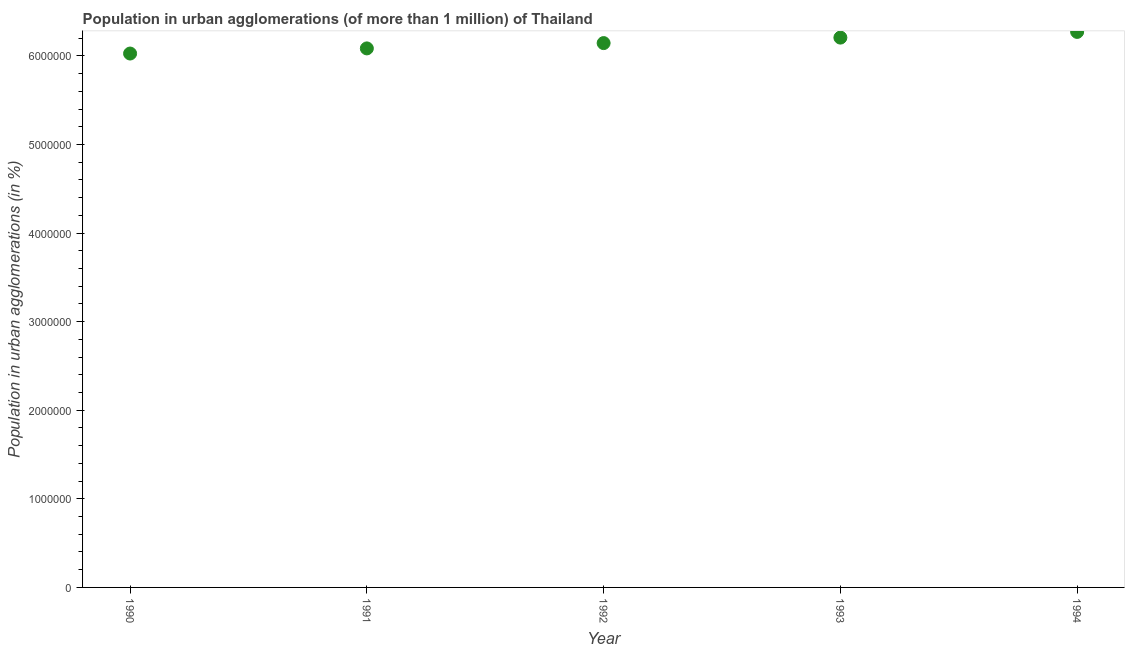What is the population in urban agglomerations in 1992?
Offer a terse response. 6.14e+06. Across all years, what is the maximum population in urban agglomerations?
Your response must be concise. 6.27e+06. Across all years, what is the minimum population in urban agglomerations?
Provide a short and direct response. 6.03e+06. What is the sum of the population in urban agglomerations?
Your response must be concise. 3.07e+07. What is the difference between the population in urban agglomerations in 1991 and 1993?
Provide a succinct answer. -1.22e+05. What is the average population in urban agglomerations per year?
Keep it short and to the point. 6.15e+06. What is the median population in urban agglomerations?
Offer a terse response. 6.14e+06. In how many years, is the population in urban agglomerations greater than 2000000 %?
Offer a terse response. 5. What is the ratio of the population in urban agglomerations in 1991 to that in 1993?
Provide a succinct answer. 0.98. Is the difference between the population in urban agglomerations in 1992 and 1994 greater than the difference between any two years?
Make the answer very short. No. What is the difference between the highest and the second highest population in urban agglomerations?
Make the answer very short. 6.43e+04. Is the sum of the population in urban agglomerations in 1990 and 1993 greater than the maximum population in urban agglomerations across all years?
Keep it short and to the point. Yes. What is the difference between the highest and the lowest population in urban agglomerations?
Offer a very short reply. 2.44e+05. How many dotlines are there?
Give a very brief answer. 1. Are the values on the major ticks of Y-axis written in scientific E-notation?
Make the answer very short. No. What is the title of the graph?
Provide a short and direct response. Population in urban agglomerations (of more than 1 million) of Thailand. What is the label or title of the X-axis?
Make the answer very short. Year. What is the label or title of the Y-axis?
Ensure brevity in your answer.  Population in urban agglomerations (in %). What is the Population in urban agglomerations (in %) in 1990?
Your response must be concise. 6.03e+06. What is the Population in urban agglomerations (in %) in 1991?
Your answer should be compact. 6.08e+06. What is the Population in urban agglomerations (in %) in 1992?
Ensure brevity in your answer.  6.14e+06. What is the Population in urban agglomerations (in %) in 1993?
Your answer should be very brief. 6.21e+06. What is the Population in urban agglomerations (in %) in 1994?
Provide a short and direct response. 6.27e+06. What is the difference between the Population in urban agglomerations (in %) in 1990 and 1991?
Provide a succinct answer. -5.79e+04. What is the difference between the Population in urban agglomerations (in %) in 1990 and 1992?
Keep it short and to the point. -1.18e+05. What is the difference between the Population in urban agglomerations (in %) in 1990 and 1993?
Your response must be concise. -1.80e+05. What is the difference between the Population in urban agglomerations (in %) in 1990 and 1994?
Offer a terse response. -2.44e+05. What is the difference between the Population in urban agglomerations (in %) in 1991 and 1992?
Your response must be concise. -6.00e+04. What is the difference between the Population in urban agglomerations (in %) in 1991 and 1993?
Give a very brief answer. -1.22e+05. What is the difference between the Population in urban agglomerations (in %) in 1991 and 1994?
Offer a terse response. -1.86e+05. What is the difference between the Population in urban agglomerations (in %) in 1992 and 1993?
Keep it short and to the point. -6.19e+04. What is the difference between the Population in urban agglomerations (in %) in 1992 and 1994?
Your response must be concise. -1.26e+05. What is the difference between the Population in urban agglomerations (in %) in 1993 and 1994?
Your answer should be very brief. -6.43e+04. What is the ratio of the Population in urban agglomerations (in %) in 1990 to that in 1992?
Provide a short and direct response. 0.98. What is the ratio of the Population in urban agglomerations (in %) in 1990 to that in 1994?
Offer a terse response. 0.96. What is the ratio of the Population in urban agglomerations (in %) in 1991 to that in 1992?
Make the answer very short. 0.99. What is the ratio of the Population in urban agglomerations (in %) in 1991 to that in 1993?
Ensure brevity in your answer.  0.98. What is the ratio of the Population in urban agglomerations (in %) in 1991 to that in 1994?
Your answer should be very brief. 0.97. What is the ratio of the Population in urban agglomerations (in %) in 1992 to that in 1994?
Your answer should be compact. 0.98. 